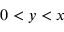<formula> <loc_0><loc_0><loc_500><loc_500>0 < y < x</formula> 